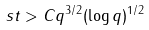Convert formula to latex. <formula><loc_0><loc_0><loc_500><loc_500>s t > C q ^ { 3 / 2 } ( \log q ) ^ { 1 / 2 }</formula> 